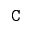Convert formula to latex. <formula><loc_0><loc_0><loc_500><loc_500>C</formula> 